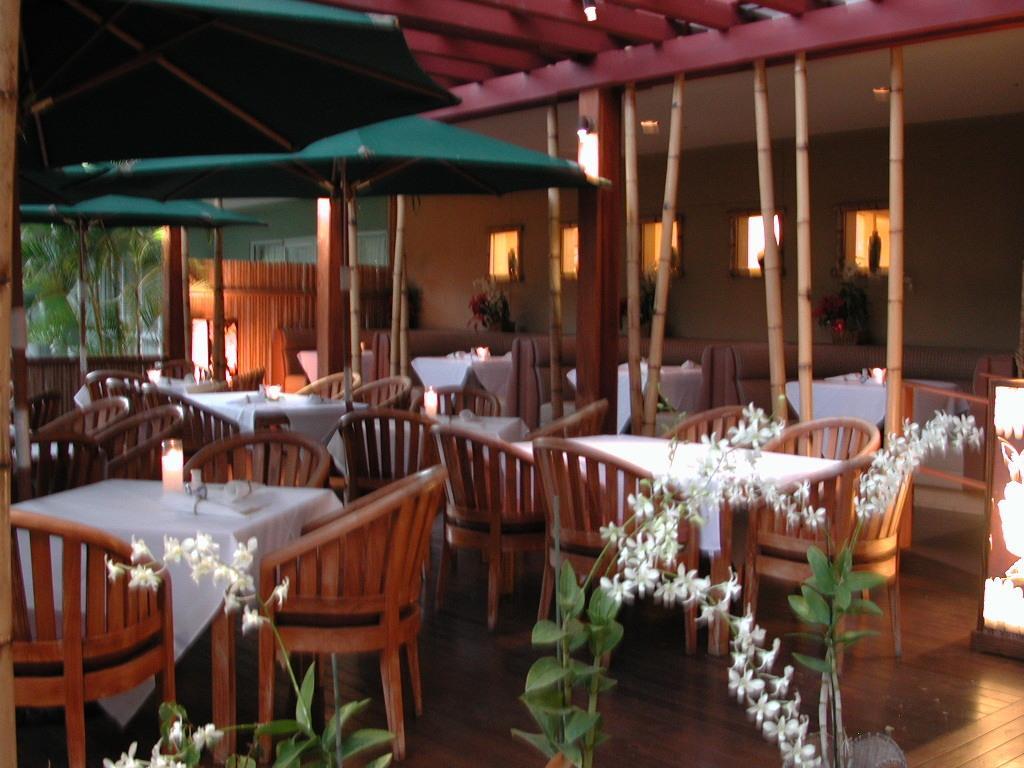Can you describe this image briefly? In this image there are tables and chairs. At the bottom there are plants and flowers. In the background we can see parasols and trees. There are lights and we can see windows. 